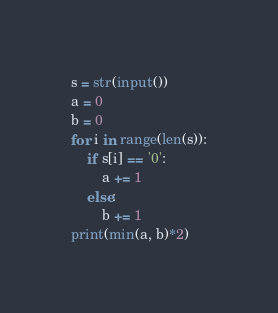Convert code to text. <code><loc_0><loc_0><loc_500><loc_500><_Python_>s = str(input())
a = 0
b = 0
for i in range(len(s)):
    if s[i] == '0':
        a += 1
    else:
        b += 1
print(min(a, b)*2)
</code> 